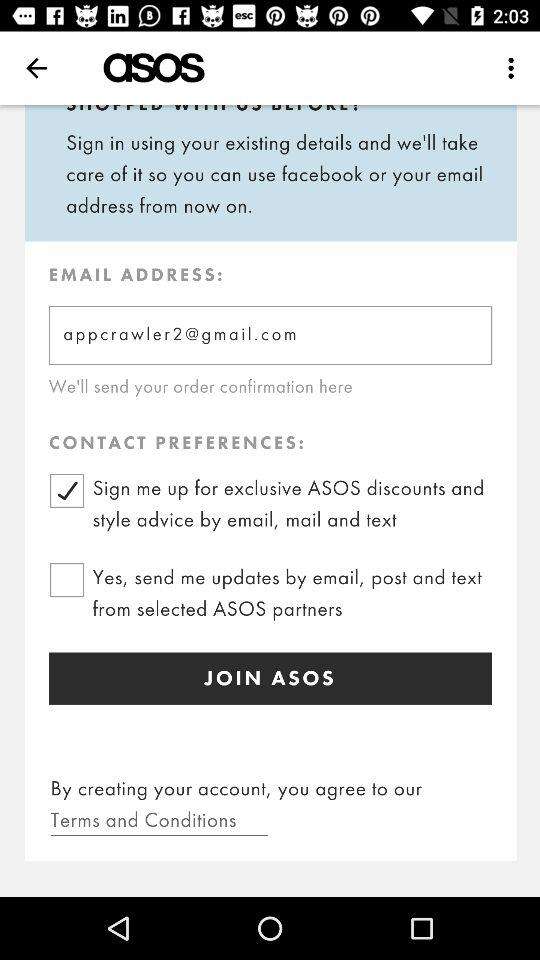How many contact preference checkboxes are there?
Answer the question using a single word or phrase. 2 